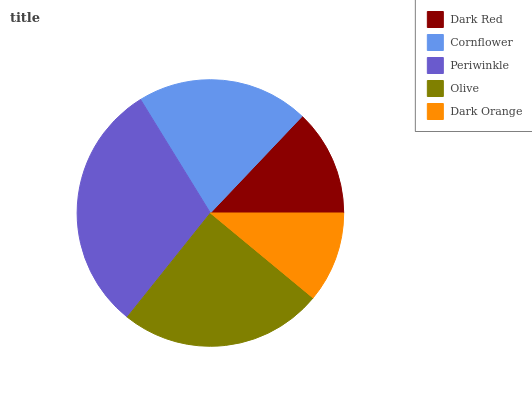Is Dark Orange the minimum?
Answer yes or no. Yes. Is Periwinkle the maximum?
Answer yes or no. Yes. Is Cornflower the minimum?
Answer yes or no. No. Is Cornflower the maximum?
Answer yes or no. No. Is Cornflower greater than Dark Red?
Answer yes or no. Yes. Is Dark Red less than Cornflower?
Answer yes or no. Yes. Is Dark Red greater than Cornflower?
Answer yes or no. No. Is Cornflower less than Dark Red?
Answer yes or no. No. Is Cornflower the high median?
Answer yes or no. Yes. Is Cornflower the low median?
Answer yes or no. Yes. Is Dark Red the high median?
Answer yes or no. No. Is Dark Red the low median?
Answer yes or no. No. 